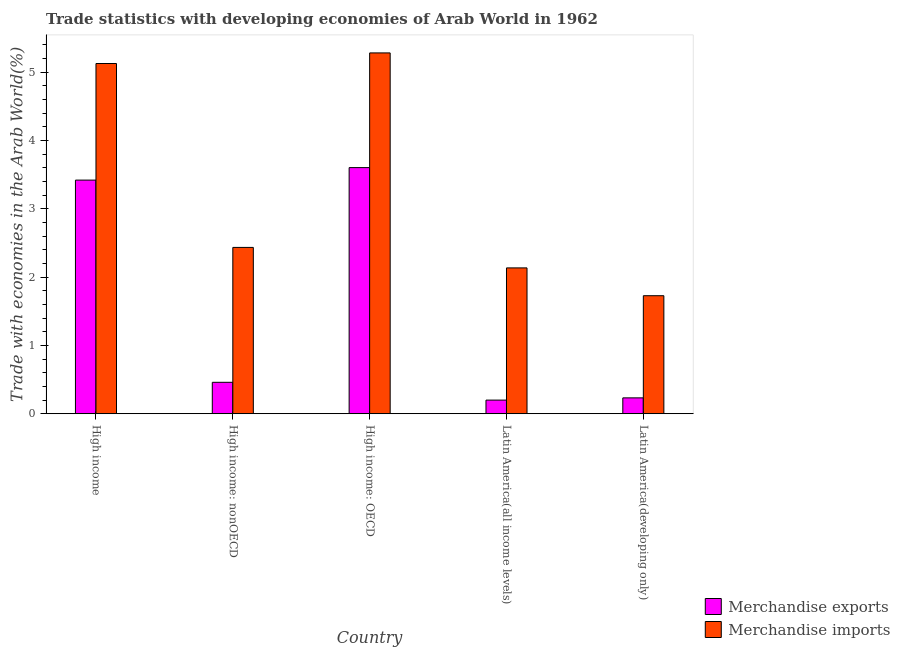How many groups of bars are there?
Offer a terse response. 5. How many bars are there on the 2nd tick from the left?
Provide a short and direct response. 2. How many bars are there on the 4th tick from the right?
Make the answer very short. 2. What is the label of the 1st group of bars from the left?
Make the answer very short. High income. In how many cases, is the number of bars for a given country not equal to the number of legend labels?
Your response must be concise. 0. What is the merchandise exports in Latin America(developing only)?
Make the answer very short. 0.23. Across all countries, what is the maximum merchandise imports?
Your response must be concise. 5.28. Across all countries, what is the minimum merchandise exports?
Provide a short and direct response. 0.2. In which country was the merchandise imports maximum?
Make the answer very short. High income: OECD. In which country was the merchandise exports minimum?
Make the answer very short. Latin America(all income levels). What is the total merchandise imports in the graph?
Provide a short and direct response. 16.7. What is the difference between the merchandise imports in High income and that in Latin America(all income levels)?
Keep it short and to the point. 2.99. What is the difference between the merchandise imports in High income: nonOECD and the merchandise exports in High income?
Offer a very short reply. -0.98. What is the average merchandise exports per country?
Provide a short and direct response. 1.58. What is the difference between the merchandise exports and merchandise imports in High income: nonOECD?
Give a very brief answer. -1.97. In how many countries, is the merchandise imports greater than 4.2 %?
Offer a terse response. 2. What is the ratio of the merchandise imports in High income: OECD to that in Latin America(developing only)?
Your response must be concise. 3.06. What is the difference between the highest and the second highest merchandise imports?
Give a very brief answer. 0.16. What is the difference between the highest and the lowest merchandise exports?
Offer a very short reply. 3.4. In how many countries, is the merchandise imports greater than the average merchandise imports taken over all countries?
Your answer should be compact. 2. Is the sum of the merchandise imports in High income: OECD and Latin America(all income levels) greater than the maximum merchandise exports across all countries?
Provide a short and direct response. Yes. What does the 1st bar from the left in High income: nonOECD represents?
Offer a very short reply. Merchandise exports. What does the 2nd bar from the right in High income: OECD represents?
Your response must be concise. Merchandise exports. How many countries are there in the graph?
Keep it short and to the point. 5. Does the graph contain any zero values?
Keep it short and to the point. No. Does the graph contain grids?
Your answer should be compact. No. Where does the legend appear in the graph?
Offer a very short reply. Bottom right. How many legend labels are there?
Ensure brevity in your answer.  2. What is the title of the graph?
Your response must be concise. Trade statistics with developing economies of Arab World in 1962. What is the label or title of the X-axis?
Offer a very short reply. Country. What is the label or title of the Y-axis?
Your response must be concise. Trade with economies in the Arab World(%). What is the Trade with economies in the Arab World(%) of Merchandise exports in High income?
Give a very brief answer. 3.42. What is the Trade with economies in the Arab World(%) in Merchandise imports in High income?
Offer a terse response. 5.12. What is the Trade with economies in the Arab World(%) of Merchandise exports in High income: nonOECD?
Offer a very short reply. 0.46. What is the Trade with economies in the Arab World(%) in Merchandise imports in High income: nonOECD?
Your answer should be very brief. 2.43. What is the Trade with economies in the Arab World(%) in Merchandise exports in High income: OECD?
Provide a short and direct response. 3.6. What is the Trade with economies in the Arab World(%) in Merchandise imports in High income: OECD?
Offer a very short reply. 5.28. What is the Trade with economies in the Arab World(%) of Merchandise exports in Latin America(all income levels)?
Provide a succinct answer. 0.2. What is the Trade with economies in the Arab World(%) of Merchandise imports in Latin America(all income levels)?
Offer a terse response. 2.13. What is the Trade with economies in the Arab World(%) of Merchandise exports in Latin America(developing only)?
Provide a short and direct response. 0.23. What is the Trade with economies in the Arab World(%) of Merchandise imports in Latin America(developing only)?
Keep it short and to the point. 1.73. Across all countries, what is the maximum Trade with economies in the Arab World(%) of Merchandise exports?
Your answer should be compact. 3.6. Across all countries, what is the maximum Trade with economies in the Arab World(%) in Merchandise imports?
Provide a succinct answer. 5.28. Across all countries, what is the minimum Trade with economies in the Arab World(%) in Merchandise exports?
Give a very brief answer. 0.2. Across all countries, what is the minimum Trade with economies in the Arab World(%) in Merchandise imports?
Your answer should be very brief. 1.73. What is the total Trade with economies in the Arab World(%) of Merchandise exports in the graph?
Your answer should be very brief. 7.91. What is the total Trade with economies in the Arab World(%) in Merchandise imports in the graph?
Your response must be concise. 16.7. What is the difference between the Trade with economies in the Arab World(%) of Merchandise exports in High income and that in High income: nonOECD?
Give a very brief answer. 2.96. What is the difference between the Trade with economies in the Arab World(%) in Merchandise imports in High income and that in High income: nonOECD?
Give a very brief answer. 2.69. What is the difference between the Trade with economies in the Arab World(%) of Merchandise exports in High income and that in High income: OECD?
Keep it short and to the point. -0.18. What is the difference between the Trade with economies in the Arab World(%) of Merchandise imports in High income and that in High income: OECD?
Keep it short and to the point. -0.15. What is the difference between the Trade with economies in the Arab World(%) in Merchandise exports in High income and that in Latin America(all income levels)?
Keep it short and to the point. 3.22. What is the difference between the Trade with economies in the Arab World(%) of Merchandise imports in High income and that in Latin America(all income levels)?
Ensure brevity in your answer.  2.99. What is the difference between the Trade with economies in the Arab World(%) in Merchandise exports in High income and that in Latin America(developing only)?
Keep it short and to the point. 3.19. What is the difference between the Trade with economies in the Arab World(%) of Merchandise imports in High income and that in Latin America(developing only)?
Offer a very short reply. 3.4. What is the difference between the Trade with economies in the Arab World(%) in Merchandise exports in High income: nonOECD and that in High income: OECD?
Offer a terse response. -3.14. What is the difference between the Trade with economies in the Arab World(%) in Merchandise imports in High income: nonOECD and that in High income: OECD?
Offer a very short reply. -2.85. What is the difference between the Trade with economies in the Arab World(%) in Merchandise exports in High income: nonOECD and that in Latin America(all income levels)?
Offer a very short reply. 0.26. What is the difference between the Trade with economies in the Arab World(%) of Merchandise imports in High income: nonOECD and that in Latin America(all income levels)?
Provide a succinct answer. 0.3. What is the difference between the Trade with economies in the Arab World(%) in Merchandise exports in High income: nonOECD and that in Latin America(developing only)?
Offer a terse response. 0.23. What is the difference between the Trade with economies in the Arab World(%) in Merchandise imports in High income: nonOECD and that in Latin America(developing only)?
Ensure brevity in your answer.  0.71. What is the difference between the Trade with economies in the Arab World(%) of Merchandise exports in High income: OECD and that in Latin America(all income levels)?
Offer a terse response. 3.4. What is the difference between the Trade with economies in the Arab World(%) of Merchandise imports in High income: OECD and that in Latin America(all income levels)?
Your response must be concise. 3.15. What is the difference between the Trade with economies in the Arab World(%) in Merchandise exports in High income: OECD and that in Latin America(developing only)?
Your response must be concise. 3.37. What is the difference between the Trade with economies in the Arab World(%) in Merchandise imports in High income: OECD and that in Latin America(developing only)?
Keep it short and to the point. 3.55. What is the difference between the Trade with economies in the Arab World(%) of Merchandise exports in Latin America(all income levels) and that in Latin America(developing only)?
Offer a very short reply. -0.03. What is the difference between the Trade with economies in the Arab World(%) of Merchandise imports in Latin America(all income levels) and that in Latin America(developing only)?
Your answer should be compact. 0.41. What is the difference between the Trade with economies in the Arab World(%) of Merchandise exports in High income and the Trade with economies in the Arab World(%) of Merchandise imports in High income: nonOECD?
Make the answer very short. 0.98. What is the difference between the Trade with economies in the Arab World(%) in Merchandise exports in High income and the Trade with economies in the Arab World(%) in Merchandise imports in High income: OECD?
Offer a very short reply. -1.86. What is the difference between the Trade with economies in the Arab World(%) in Merchandise exports in High income and the Trade with economies in the Arab World(%) in Merchandise imports in Latin America(all income levels)?
Provide a succinct answer. 1.28. What is the difference between the Trade with economies in the Arab World(%) in Merchandise exports in High income and the Trade with economies in the Arab World(%) in Merchandise imports in Latin America(developing only)?
Ensure brevity in your answer.  1.69. What is the difference between the Trade with economies in the Arab World(%) in Merchandise exports in High income: nonOECD and the Trade with economies in the Arab World(%) in Merchandise imports in High income: OECD?
Offer a terse response. -4.82. What is the difference between the Trade with economies in the Arab World(%) in Merchandise exports in High income: nonOECD and the Trade with economies in the Arab World(%) in Merchandise imports in Latin America(all income levels)?
Keep it short and to the point. -1.67. What is the difference between the Trade with economies in the Arab World(%) of Merchandise exports in High income: nonOECD and the Trade with economies in the Arab World(%) of Merchandise imports in Latin America(developing only)?
Your answer should be compact. -1.27. What is the difference between the Trade with economies in the Arab World(%) in Merchandise exports in High income: OECD and the Trade with economies in the Arab World(%) in Merchandise imports in Latin America(all income levels)?
Provide a short and direct response. 1.47. What is the difference between the Trade with economies in the Arab World(%) in Merchandise exports in High income: OECD and the Trade with economies in the Arab World(%) in Merchandise imports in Latin America(developing only)?
Your answer should be compact. 1.87. What is the difference between the Trade with economies in the Arab World(%) of Merchandise exports in Latin America(all income levels) and the Trade with economies in the Arab World(%) of Merchandise imports in Latin America(developing only)?
Offer a terse response. -1.53. What is the average Trade with economies in the Arab World(%) of Merchandise exports per country?
Keep it short and to the point. 1.58. What is the average Trade with economies in the Arab World(%) in Merchandise imports per country?
Your response must be concise. 3.34. What is the difference between the Trade with economies in the Arab World(%) in Merchandise exports and Trade with economies in the Arab World(%) in Merchandise imports in High income?
Ensure brevity in your answer.  -1.71. What is the difference between the Trade with economies in the Arab World(%) of Merchandise exports and Trade with economies in the Arab World(%) of Merchandise imports in High income: nonOECD?
Provide a short and direct response. -1.97. What is the difference between the Trade with economies in the Arab World(%) in Merchandise exports and Trade with economies in the Arab World(%) in Merchandise imports in High income: OECD?
Offer a terse response. -1.68. What is the difference between the Trade with economies in the Arab World(%) in Merchandise exports and Trade with economies in the Arab World(%) in Merchandise imports in Latin America(all income levels)?
Offer a terse response. -1.93. What is the difference between the Trade with economies in the Arab World(%) of Merchandise exports and Trade with economies in the Arab World(%) of Merchandise imports in Latin America(developing only)?
Make the answer very short. -1.49. What is the ratio of the Trade with economies in the Arab World(%) of Merchandise exports in High income to that in High income: nonOECD?
Ensure brevity in your answer.  7.43. What is the ratio of the Trade with economies in the Arab World(%) in Merchandise imports in High income to that in High income: nonOECD?
Your response must be concise. 2.11. What is the ratio of the Trade with economies in the Arab World(%) in Merchandise exports in High income to that in High income: OECD?
Provide a succinct answer. 0.95. What is the ratio of the Trade with economies in the Arab World(%) of Merchandise imports in High income to that in High income: OECD?
Keep it short and to the point. 0.97. What is the ratio of the Trade with economies in the Arab World(%) in Merchandise exports in High income to that in Latin America(all income levels)?
Make the answer very short. 17.14. What is the ratio of the Trade with economies in the Arab World(%) of Merchandise imports in High income to that in Latin America(all income levels)?
Provide a short and direct response. 2.4. What is the ratio of the Trade with economies in the Arab World(%) in Merchandise exports in High income to that in Latin America(developing only)?
Offer a terse response. 14.72. What is the ratio of the Trade with economies in the Arab World(%) in Merchandise imports in High income to that in Latin America(developing only)?
Offer a terse response. 2.97. What is the ratio of the Trade with economies in the Arab World(%) in Merchandise exports in High income: nonOECD to that in High income: OECD?
Your answer should be compact. 0.13. What is the ratio of the Trade with economies in the Arab World(%) of Merchandise imports in High income: nonOECD to that in High income: OECD?
Make the answer very short. 0.46. What is the ratio of the Trade with economies in the Arab World(%) in Merchandise exports in High income: nonOECD to that in Latin America(all income levels)?
Offer a very short reply. 2.31. What is the ratio of the Trade with economies in the Arab World(%) of Merchandise imports in High income: nonOECD to that in Latin America(all income levels)?
Ensure brevity in your answer.  1.14. What is the ratio of the Trade with economies in the Arab World(%) in Merchandise exports in High income: nonOECD to that in Latin America(developing only)?
Offer a very short reply. 1.98. What is the ratio of the Trade with economies in the Arab World(%) of Merchandise imports in High income: nonOECD to that in Latin America(developing only)?
Keep it short and to the point. 1.41. What is the ratio of the Trade with economies in the Arab World(%) of Merchandise exports in High income: OECD to that in Latin America(all income levels)?
Provide a short and direct response. 18.05. What is the ratio of the Trade with economies in the Arab World(%) of Merchandise imports in High income: OECD to that in Latin America(all income levels)?
Provide a short and direct response. 2.47. What is the ratio of the Trade with economies in the Arab World(%) in Merchandise exports in High income: OECD to that in Latin America(developing only)?
Offer a very short reply. 15.51. What is the ratio of the Trade with economies in the Arab World(%) of Merchandise imports in High income: OECD to that in Latin America(developing only)?
Offer a terse response. 3.06. What is the ratio of the Trade with economies in the Arab World(%) of Merchandise exports in Latin America(all income levels) to that in Latin America(developing only)?
Your response must be concise. 0.86. What is the ratio of the Trade with economies in the Arab World(%) in Merchandise imports in Latin America(all income levels) to that in Latin America(developing only)?
Your answer should be compact. 1.24. What is the difference between the highest and the second highest Trade with economies in the Arab World(%) in Merchandise exports?
Offer a very short reply. 0.18. What is the difference between the highest and the second highest Trade with economies in the Arab World(%) of Merchandise imports?
Ensure brevity in your answer.  0.15. What is the difference between the highest and the lowest Trade with economies in the Arab World(%) in Merchandise exports?
Keep it short and to the point. 3.4. What is the difference between the highest and the lowest Trade with economies in the Arab World(%) of Merchandise imports?
Provide a short and direct response. 3.55. 